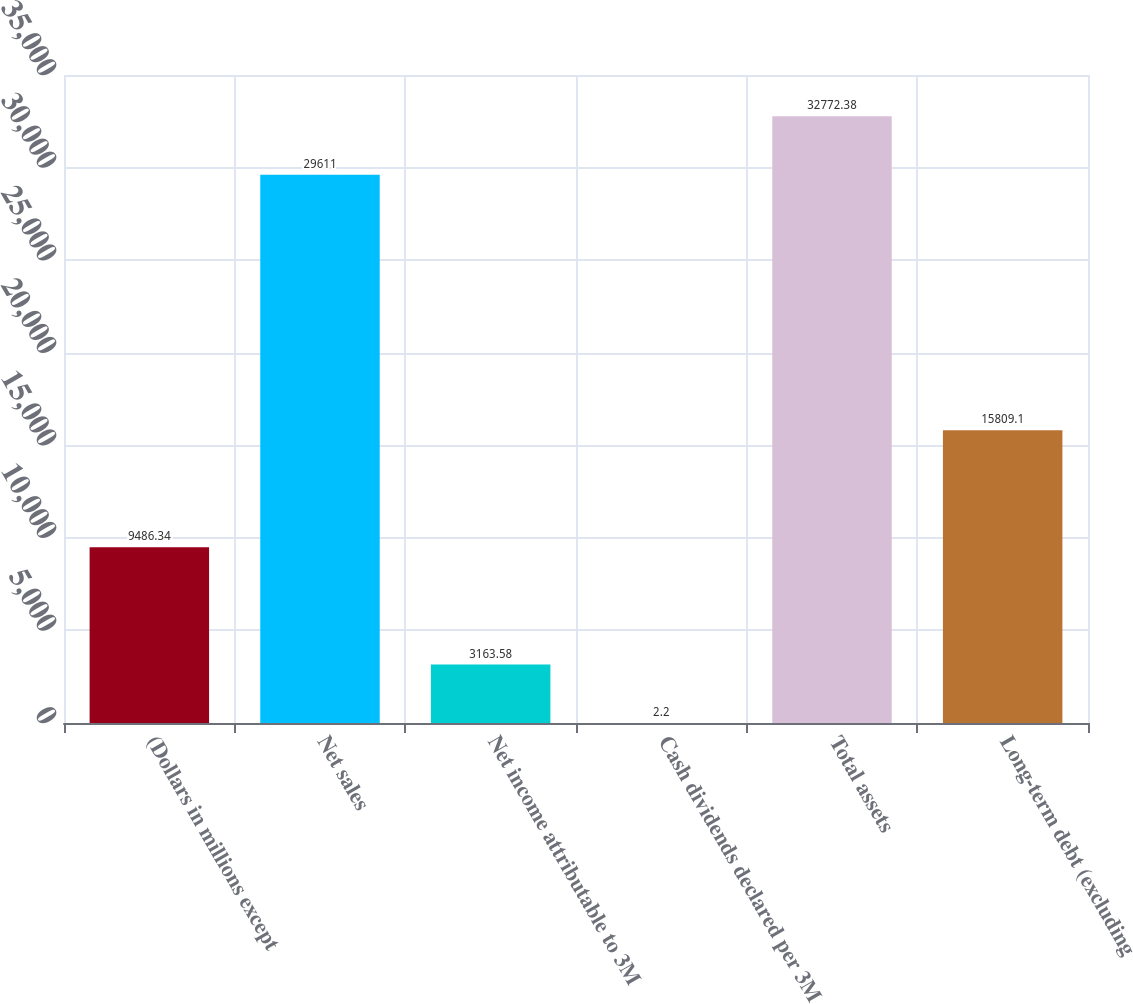<chart> <loc_0><loc_0><loc_500><loc_500><bar_chart><fcel>(Dollars in millions except<fcel>Net sales<fcel>Net income attributable to 3M<fcel>Cash dividends declared per 3M<fcel>Total assets<fcel>Long-term debt (excluding<nl><fcel>9486.34<fcel>29611<fcel>3163.58<fcel>2.2<fcel>32772.4<fcel>15809.1<nl></chart> 